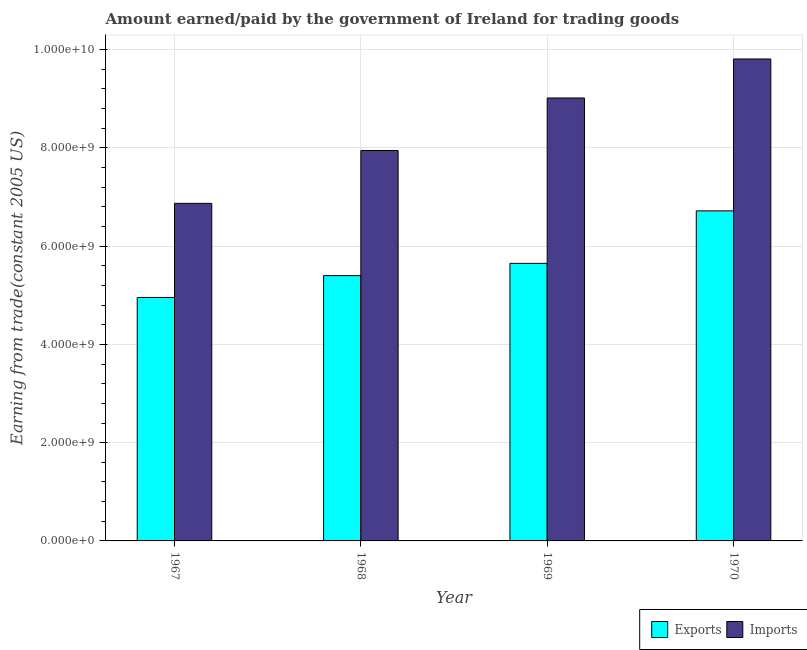How many different coloured bars are there?
Offer a very short reply. 2. How many groups of bars are there?
Provide a succinct answer. 4. Are the number of bars per tick equal to the number of legend labels?
Give a very brief answer. Yes. How many bars are there on the 3rd tick from the left?
Give a very brief answer. 2. How many bars are there on the 4th tick from the right?
Your response must be concise. 2. What is the label of the 1st group of bars from the left?
Your response must be concise. 1967. In how many cases, is the number of bars for a given year not equal to the number of legend labels?
Your answer should be compact. 0. What is the amount paid for imports in 1968?
Your answer should be very brief. 7.95e+09. Across all years, what is the maximum amount paid for imports?
Provide a succinct answer. 9.81e+09. Across all years, what is the minimum amount paid for imports?
Ensure brevity in your answer.  6.87e+09. In which year was the amount paid for imports minimum?
Ensure brevity in your answer.  1967. What is the total amount earned from exports in the graph?
Your answer should be compact. 2.27e+1. What is the difference between the amount earned from exports in 1968 and that in 1969?
Your answer should be compact. -2.50e+08. What is the difference between the amount earned from exports in 1969 and the amount paid for imports in 1968?
Offer a very short reply. 2.50e+08. What is the average amount earned from exports per year?
Offer a very short reply. 5.68e+09. In the year 1969, what is the difference between the amount paid for imports and amount earned from exports?
Provide a succinct answer. 0. What is the ratio of the amount earned from exports in 1967 to that in 1969?
Offer a terse response. 0.88. Is the amount paid for imports in 1968 less than that in 1969?
Ensure brevity in your answer.  Yes. What is the difference between the highest and the second highest amount earned from exports?
Your answer should be compact. 1.07e+09. What is the difference between the highest and the lowest amount paid for imports?
Your answer should be very brief. 2.94e+09. In how many years, is the amount earned from exports greater than the average amount earned from exports taken over all years?
Provide a short and direct response. 1. Is the sum of the amount paid for imports in 1967 and 1969 greater than the maximum amount earned from exports across all years?
Keep it short and to the point. Yes. What does the 2nd bar from the left in 1970 represents?
Offer a terse response. Imports. What does the 2nd bar from the right in 1969 represents?
Keep it short and to the point. Exports. How many bars are there?
Ensure brevity in your answer.  8. Are the values on the major ticks of Y-axis written in scientific E-notation?
Keep it short and to the point. Yes. Does the graph contain any zero values?
Your answer should be very brief. No. Does the graph contain grids?
Your answer should be very brief. Yes. Where does the legend appear in the graph?
Provide a succinct answer. Bottom right. What is the title of the graph?
Make the answer very short. Amount earned/paid by the government of Ireland for trading goods. Does "Working only" appear as one of the legend labels in the graph?
Your response must be concise. No. What is the label or title of the Y-axis?
Your answer should be compact. Earning from trade(constant 2005 US). What is the Earning from trade(constant 2005 US) of Exports in 1967?
Offer a very short reply. 4.96e+09. What is the Earning from trade(constant 2005 US) of Imports in 1967?
Ensure brevity in your answer.  6.87e+09. What is the Earning from trade(constant 2005 US) in Exports in 1968?
Offer a very short reply. 5.40e+09. What is the Earning from trade(constant 2005 US) in Imports in 1968?
Give a very brief answer. 7.95e+09. What is the Earning from trade(constant 2005 US) of Exports in 1969?
Offer a terse response. 5.65e+09. What is the Earning from trade(constant 2005 US) in Imports in 1969?
Your response must be concise. 9.02e+09. What is the Earning from trade(constant 2005 US) of Exports in 1970?
Provide a short and direct response. 6.72e+09. What is the Earning from trade(constant 2005 US) in Imports in 1970?
Keep it short and to the point. 9.81e+09. Across all years, what is the maximum Earning from trade(constant 2005 US) of Exports?
Your answer should be very brief. 6.72e+09. Across all years, what is the maximum Earning from trade(constant 2005 US) in Imports?
Your answer should be very brief. 9.81e+09. Across all years, what is the minimum Earning from trade(constant 2005 US) in Exports?
Your response must be concise. 4.96e+09. Across all years, what is the minimum Earning from trade(constant 2005 US) of Imports?
Offer a very short reply. 6.87e+09. What is the total Earning from trade(constant 2005 US) in Exports in the graph?
Your answer should be compact. 2.27e+1. What is the total Earning from trade(constant 2005 US) in Imports in the graph?
Keep it short and to the point. 3.36e+1. What is the difference between the Earning from trade(constant 2005 US) in Exports in 1967 and that in 1968?
Offer a terse response. -4.44e+08. What is the difference between the Earning from trade(constant 2005 US) of Imports in 1967 and that in 1968?
Offer a very short reply. -1.08e+09. What is the difference between the Earning from trade(constant 2005 US) of Exports in 1967 and that in 1969?
Your answer should be very brief. -6.94e+08. What is the difference between the Earning from trade(constant 2005 US) of Imports in 1967 and that in 1969?
Offer a very short reply. -2.15e+09. What is the difference between the Earning from trade(constant 2005 US) in Exports in 1967 and that in 1970?
Offer a very short reply. -1.76e+09. What is the difference between the Earning from trade(constant 2005 US) of Imports in 1967 and that in 1970?
Keep it short and to the point. -2.94e+09. What is the difference between the Earning from trade(constant 2005 US) of Exports in 1968 and that in 1969?
Make the answer very short. -2.50e+08. What is the difference between the Earning from trade(constant 2005 US) in Imports in 1968 and that in 1969?
Your answer should be very brief. -1.07e+09. What is the difference between the Earning from trade(constant 2005 US) of Exports in 1968 and that in 1970?
Provide a succinct answer. -1.32e+09. What is the difference between the Earning from trade(constant 2005 US) of Imports in 1968 and that in 1970?
Offer a very short reply. -1.86e+09. What is the difference between the Earning from trade(constant 2005 US) of Exports in 1969 and that in 1970?
Your answer should be compact. -1.07e+09. What is the difference between the Earning from trade(constant 2005 US) in Imports in 1969 and that in 1970?
Your answer should be very brief. -7.94e+08. What is the difference between the Earning from trade(constant 2005 US) in Exports in 1967 and the Earning from trade(constant 2005 US) in Imports in 1968?
Make the answer very short. -2.99e+09. What is the difference between the Earning from trade(constant 2005 US) in Exports in 1967 and the Earning from trade(constant 2005 US) in Imports in 1969?
Give a very brief answer. -4.06e+09. What is the difference between the Earning from trade(constant 2005 US) of Exports in 1967 and the Earning from trade(constant 2005 US) of Imports in 1970?
Keep it short and to the point. -4.85e+09. What is the difference between the Earning from trade(constant 2005 US) in Exports in 1968 and the Earning from trade(constant 2005 US) in Imports in 1969?
Your answer should be compact. -3.62e+09. What is the difference between the Earning from trade(constant 2005 US) of Exports in 1968 and the Earning from trade(constant 2005 US) of Imports in 1970?
Provide a succinct answer. -4.41e+09. What is the difference between the Earning from trade(constant 2005 US) in Exports in 1969 and the Earning from trade(constant 2005 US) in Imports in 1970?
Give a very brief answer. -4.16e+09. What is the average Earning from trade(constant 2005 US) in Exports per year?
Ensure brevity in your answer.  5.68e+09. What is the average Earning from trade(constant 2005 US) in Imports per year?
Your answer should be compact. 8.41e+09. In the year 1967, what is the difference between the Earning from trade(constant 2005 US) of Exports and Earning from trade(constant 2005 US) of Imports?
Your answer should be compact. -1.92e+09. In the year 1968, what is the difference between the Earning from trade(constant 2005 US) of Exports and Earning from trade(constant 2005 US) of Imports?
Your answer should be compact. -2.55e+09. In the year 1969, what is the difference between the Earning from trade(constant 2005 US) in Exports and Earning from trade(constant 2005 US) in Imports?
Your answer should be compact. -3.37e+09. In the year 1970, what is the difference between the Earning from trade(constant 2005 US) in Exports and Earning from trade(constant 2005 US) in Imports?
Your answer should be very brief. -3.09e+09. What is the ratio of the Earning from trade(constant 2005 US) of Exports in 1967 to that in 1968?
Provide a short and direct response. 0.92. What is the ratio of the Earning from trade(constant 2005 US) in Imports in 1967 to that in 1968?
Your answer should be compact. 0.86. What is the ratio of the Earning from trade(constant 2005 US) in Exports in 1967 to that in 1969?
Provide a succinct answer. 0.88. What is the ratio of the Earning from trade(constant 2005 US) in Imports in 1967 to that in 1969?
Provide a short and direct response. 0.76. What is the ratio of the Earning from trade(constant 2005 US) in Exports in 1967 to that in 1970?
Offer a terse response. 0.74. What is the ratio of the Earning from trade(constant 2005 US) of Imports in 1967 to that in 1970?
Give a very brief answer. 0.7. What is the ratio of the Earning from trade(constant 2005 US) of Exports in 1968 to that in 1969?
Your response must be concise. 0.96. What is the ratio of the Earning from trade(constant 2005 US) of Imports in 1968 to that in 1969?
Provide a short and direct response. 0.88. What is the ratio of the Earning from trade(constant 2005 US) of Exports in 1968 to that in 1970?
Your answer should be compact. 0.8. What is the ratio of the Earning from trade(constant 2005 US) of Imports in 1968 to that in 1970?
Offer a terse response. 0.81. What is the ratio of the Earning from trade(constant 2005 US) of Exports in 1969 to that in 1970?
Your answer should be very brief. 0.84. What is the ratio of the Earning from trade(constant 2005 US) in Imports in 1969 to that in 1970?
Ensure brevity in your answer.  0.92. What is the difference between the highest and the second highest Earning from trade(constant 2005 US) of Exports?
Provide a short and direct response. 1.07e+09. What is the difference between the highest and the second highest Earning from trade(constant 2005 US) of Imports?
Your response must be concise. 7.94e+08. What is the difference between the highest and the lowest Earning from trade(constant 2005 US) of Exports?
Keep it short and to the point. 1.76e+09. What is the difference between the highest and the lowest Earning from trade(constant 2005 US) in Imports?
Offer a terse response. 2.94e+09. 